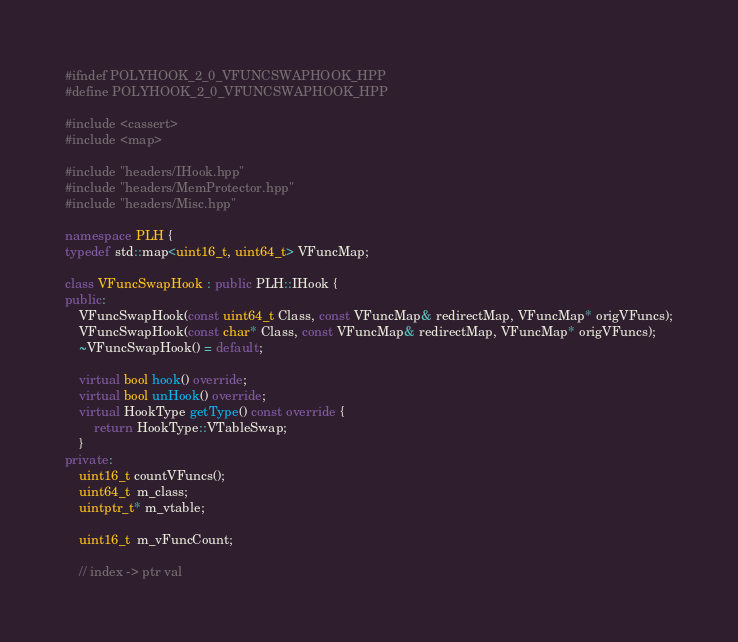<code> <loc_0><loc_0><loc_500><loc_500><_C++_>#ifndef POLYHOOK_2_0_VFUNCSWAPHOOK_HPP
#define POLYHOOK_2_0_VFUNCSWAPHOOK_HPP

#include <cassert>
#include <map>

#include "headers/IHook.hpp"
#include "headers/MemProtector.hpp"
#include "headers/Misc.hpp"

namespace PLH {
typedef std::map<uint16_t, uint64_t> VFuncMap;

class VFuncSwapHook : public PLH::IHook {
public:
	VFuncSwapHook(const uint64_t Class, const VFuncMap& redirectMap, VFuncMap* origVFuncs);
	VFuncSwapHook(const char* Class, const VFuncMap& redirectMap, VFuncMap* origVFuncs);
	~VFuncSwapHook() = default;

	virtual bool hook() override;
	virtual bool unHook() override;
	virtual HookType getType() const override {
		return HookType::VTableSwap;
	}
private:
	uint16_t countVFuncs();
	uint64_t  m_class;
	uintptr_t* m_vtable;

	uint16_t  m_vFuncCount;

	// index -> ptr val </code> 